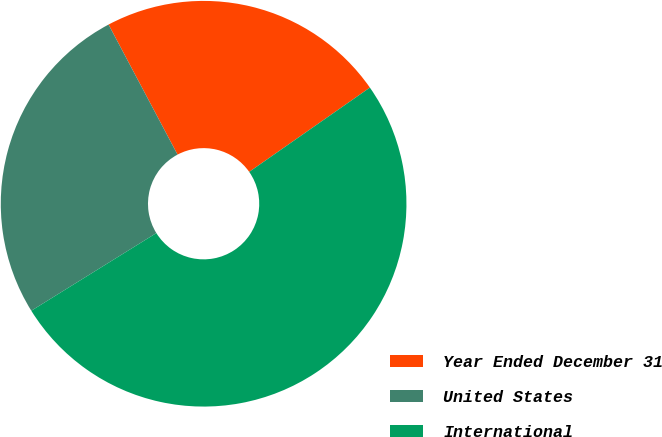Convert chart. <chart><loc_0><loc_0><loc_500><loc_500><pie_chart><fcel>Year Ended December 31<fcel>United States<fcel>International<nl><fcel>23.06%<fcel>26.08%<fcel>50.86%<nl></chart> 